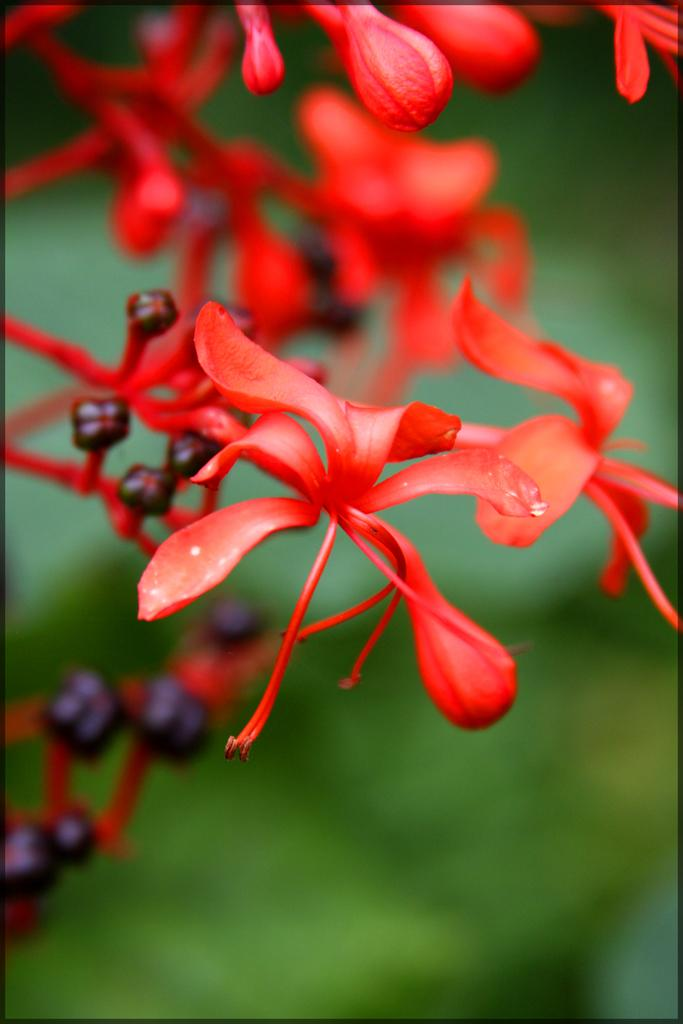What type of living organisms can be seen in the image? There are flowers in the image. What type of quilt can be seen floating on the water in the image? There is no quilt or water present in the image; it only features flowers. 